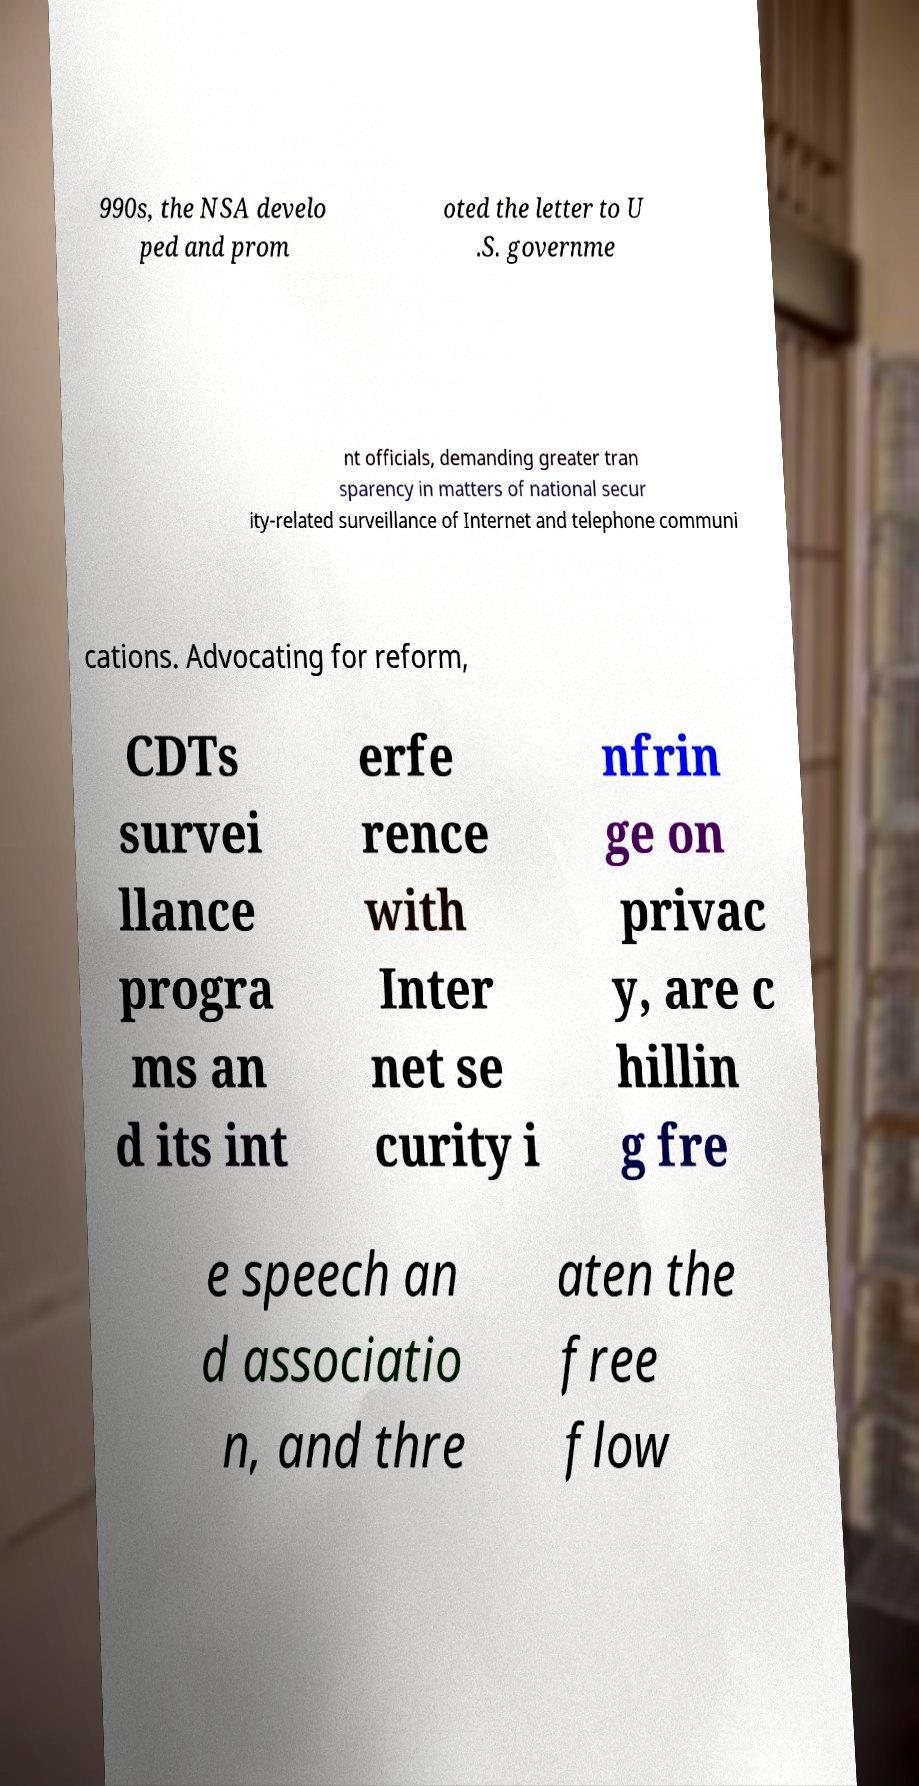Please read and relay the text visible in this image. What does it say? 990s, the NSA develo ped and prom oted the letter to U .S. governme nt officials, demanding greater tran sparency in matters of national secur ity-related surveillance of Internet and telephone communi cations. Advocating for reform, CDTs survei llance progra ms an d its int erfe rence with Inter net se curity i nfrin ge on privac y, are c hillin g fre e speech an d associatio n, and thre aten the free flow 